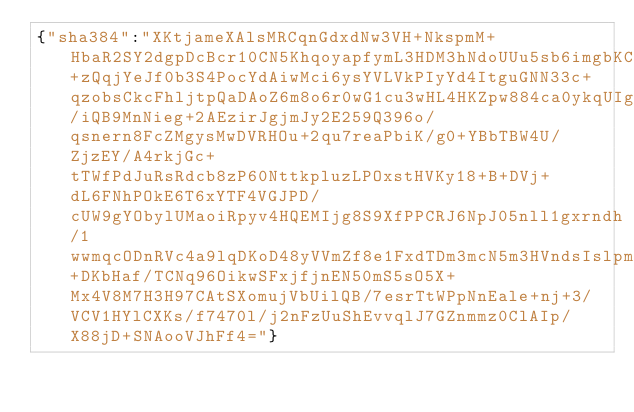Convert code to text. <code><loc_0><loc_0><loc_500><loc_500><_SML_>{"sha384":"XKtjameXAlsMRCqnGdxdNw3VH+NkspmM+HbaR2SY2dgpDcBcr10CN5KhqoyapfymL3HDM3hNdoUUu5sb6imgbKCUk4ANvMk8l1T+zQqjYeJf0b3S4PocYdAiwMci6ysYVLVkPIyYd4ItguGNN33c+qzobsCkcFhljtpQaDAoZ6m8o6r0wG1cu3wHL4HKZpw884ca0ykqUIg59WGJnfp8xuN6o2tltMci7hd163w9QUu06RCZj/iQB9MnNieg+2AEzirJgjmJy2E259Q396o/qsnern8FcZMgysMwDVRHOu+2qu7reaPbiK/g0+YBbTBW4U/ZjzEY/A4rkjGc+tTWfPdJuRsRdcb8zP60NttkpluzLPOxstHVKy18+B+DVj+dL6FNhPOkE6T6xYTF4VGJPD/cUW9gYObylUMaoiRpyv4HQEMIjg8S9XfPPCRJ6NpJ05nll1gxrndh/1wwmqcODnRVc4a9lqDKoD48yVVmZf8e1FxdTDm3mcN5m3HVndsIslpmDII5XywYQE3D8zT+DKbHaf/TCNq96OikwSFxjfjnEN50mS5sO5X+Mx4V8M7H3H97CAtSXomujVbUilQB/7esrTtWPpNnEale+nj+3/VCV1HYlCXKs/f7470l/j2nFzUuShEvvqlJ7GZnmmz0ClAIp/X88jD+SNAooVJhFf4="}</code> 